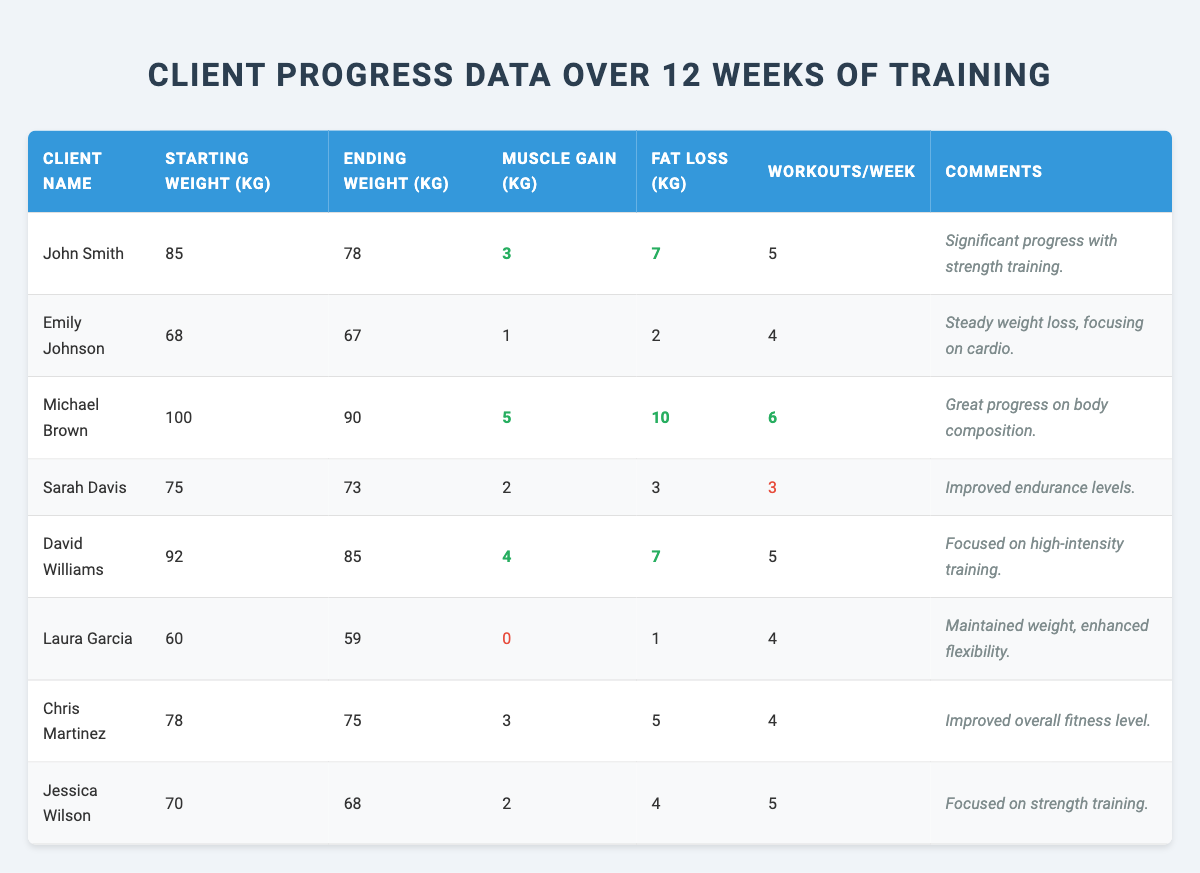What is the starting weight of Michael Brown? Michael Brown's starting weight is found in the corresponding table row, which shows "Starting Weight (kg)" as 100.
Answer: 100 kg How much muscle did Jessica Wilson gain? The muscle gain for Jessica Wilson is stated in the table under "Muscle Gain (kg)," showing a value of 2.
Answer: 2 kg Which client lost the most weight? Comparing the "Fat Loss (kg)" values for all clients, Michael Brown lost 10 kg, which is the highest value recorded in the table.
Answer: Michael Brown What is the average fat loss across all clients? To find the average fat loss, sum all individual fat losses: (7 + 2 + 10 + 3 + 7 + 1 + 5 + 4) = 39 kg. There are 8 clients, so the average is 39/8 = 4.875 kg.
Answer: 4.875 kg Did any client gain zero muscle over the training period? Looking for the "Muscle Gain (kg)" values in the table shows that Laura Garcia had a muscle gain of 0 kg. This confirms the answer is true.
Answer: Yes Which client had the highest number of workouts per week? By examining the "Workouts/Week" column, we see that Michael Brown had 6 workouts, which is the highest value listed.
Answer: Michael Brown What is the difference in starting and ending weight for Sarah Davis? Sarah Davis started at 75 kg and ended at 73 kg. Therefore, the difference is 75 - 73 = 2 kg.
Answer: 2 kg Which client achieved the highest muscle gain and fat loss combined? Calculate the total for each client: John Smith (3 + 7 = 10), Emily Johnson (1 + 2 = 3), Michael Brown (5 + 10 = 15), Sarah Davis (2 + 3 = 5), David Williams (4 + 7 = 11), Laura Garcia (0 + 1 = 1), Chris Martinez (3 + 5 = 8), Jessica Wilson (2 + 4 = 6). Michael Brown has the highest total at 15.
Answer: Michael Brown Did any client have a negative change in weight over the 12 weeks? Looking at the difference between starting and ending weights, all clients except for Emily Johnson and Laura Garcia lost weight. Hence, only these two clients did not have a negative change.
Answer: No How many clients worked out 4 or more times per week? Reviewing the "Workouts/Week" column, the clients with 4 or more workouts are Michael Brown (6), John Smith (5), David Williams (5), Jessica Wilson (5), Emily Johnson (4), Chris Martinez (4), and Laura Garcia (4). This totals 7 clients.
Answer: 7 clients 